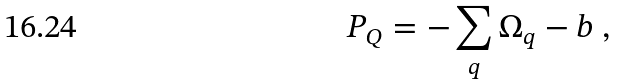Convert formula to latex. <formula><loc_0><loc_0><loc_500><loc_500>P _ { Q } = - \sum _ { q } \Omega _ { q } - b \ ,</formula> 